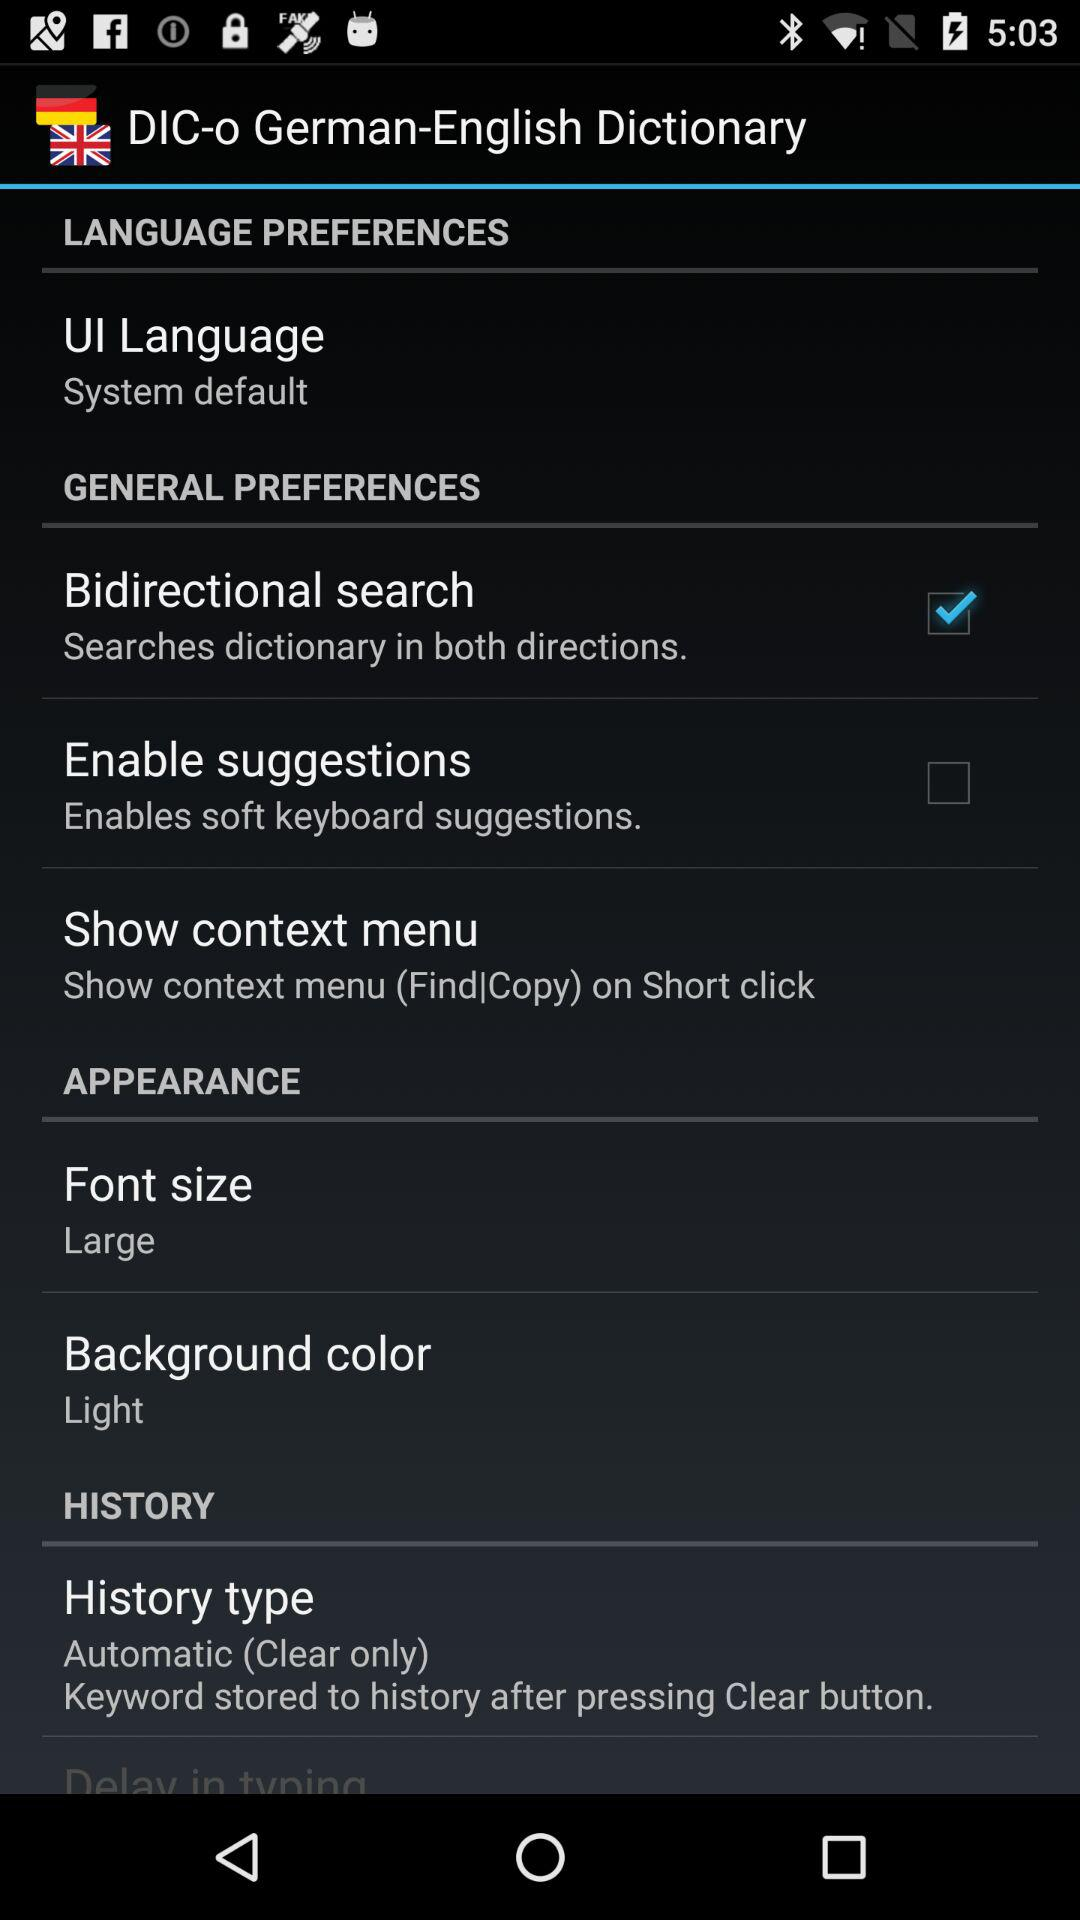Is "Enable suggestions" checked or unchecked?
Answer the question using a single word or phrase. It is unchecked. 